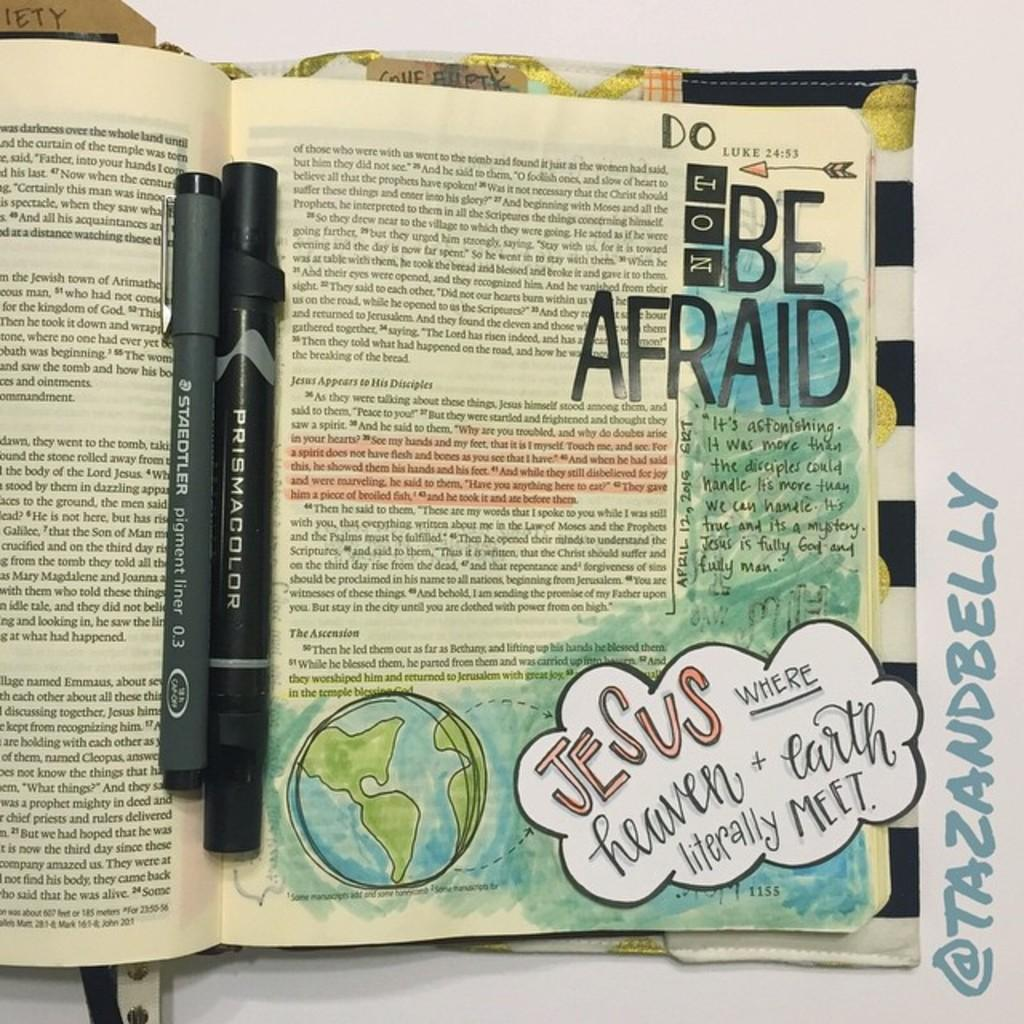Provide a one-sentence caption for the provided image. Somebody has written the words Do Not Be Afriad inside of a Bible. 